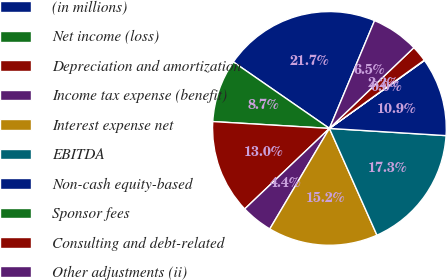Convert chart. <chart><loc_0><loc_0><loc_500><loc_500><pie_chart><fcel>(in millions)<fcel>Net income (loss)<fcel>Depreciation and amortization<fcel>Income tax expense (benefit)<fcel>Interest expense net<fcel>EBITDA<fcel>Non-cash equity-based<fcel>Sponsor fees<fcel>Consulting and debt-related<fcel>Other adjustments (ii)<nl><fcel>21.68%<fcel>8.7%<fcel>13.03%<fcel>4.38%<fcel>15.19%<fcel>17.35%<fcel>10.86%<fcel>0.05%<fcel>2.22%<fcel>6.54%<nl></chart> 